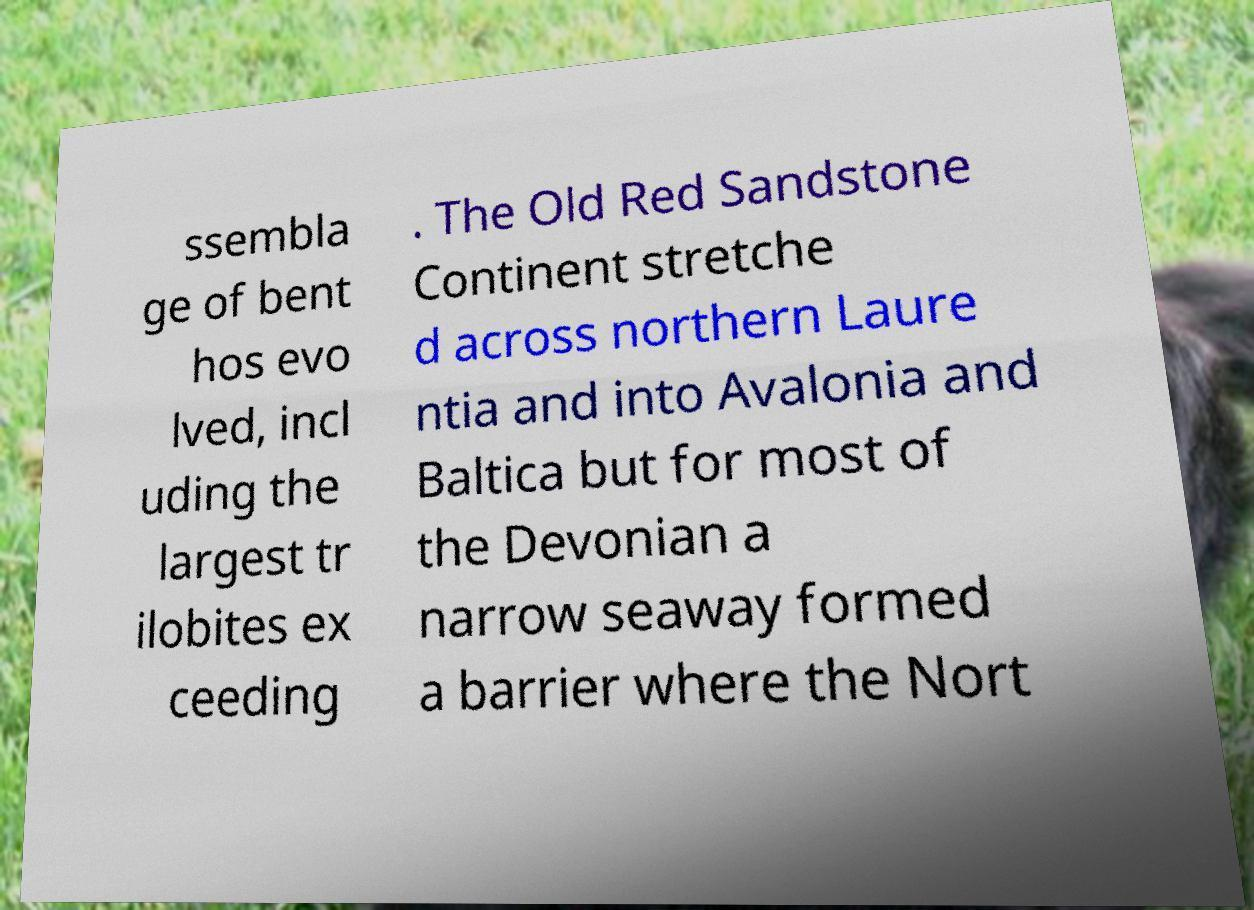There's text embedded in this image that I need extracted. Can you transcribe it verbatim? ssembla ge of bent hos evo lved, incl uding the largest tr ilobites ex ceeding . The Old Red Sandstone Continent stretche d across northern Laure ntia and into Avalonia and Baltica but for most of the Devonian a narrow seaway formed a barrier where the Nort 